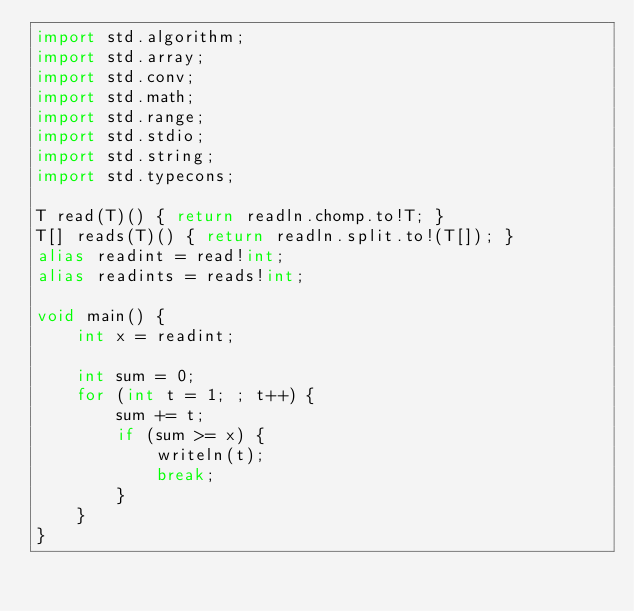Convert code to text. <code><loc_0><loc_0><loc_500><loc_500><_D_>import std.algorithm;
import std.array;
import std.conv;
import std.math;
import std.range;
import std.stdio;
import std.string;
import std.typecons;

T read(T)() { return readln.chomp.to!T; }
T[] reads(T)() { return readln.split.to!(T[]); }
alias readint = read!int;
alias readints = reads!int;

void main() {
    int x = readint;

    int sum = 0;
    for (int t = 1; ; t++) {
        sum += t;
        if (sum >= x) {
            writeln(t);
            break;
        }
    }
}
</code> 